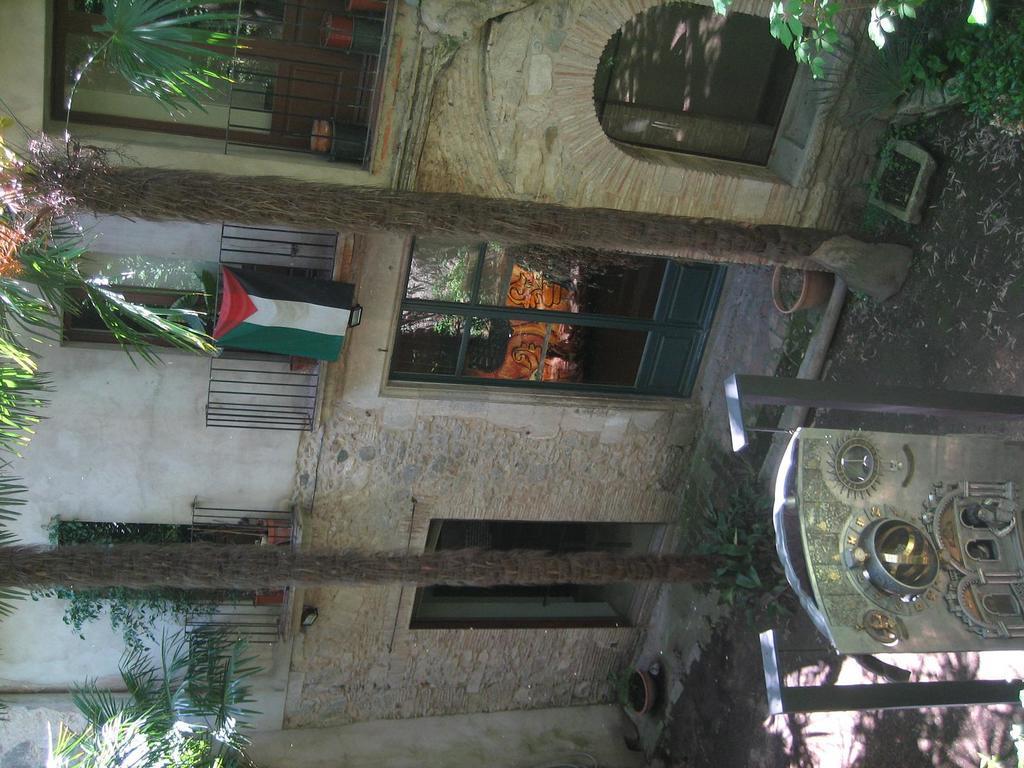How would you summarize this image in a sentence or two? In the image we can see a building, fence, flag of a country and trees. This is a pot, sand and an object. 